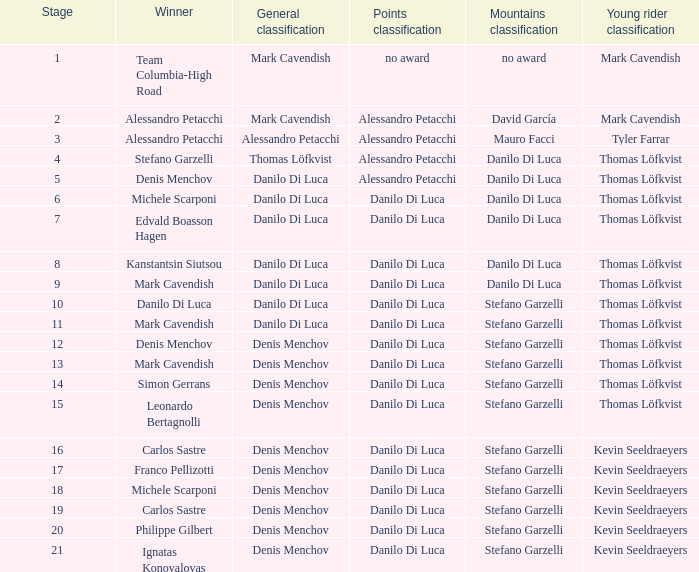Who is the winner of the general classification when thomas löfkvist is involved? Stefano Garzelli. 